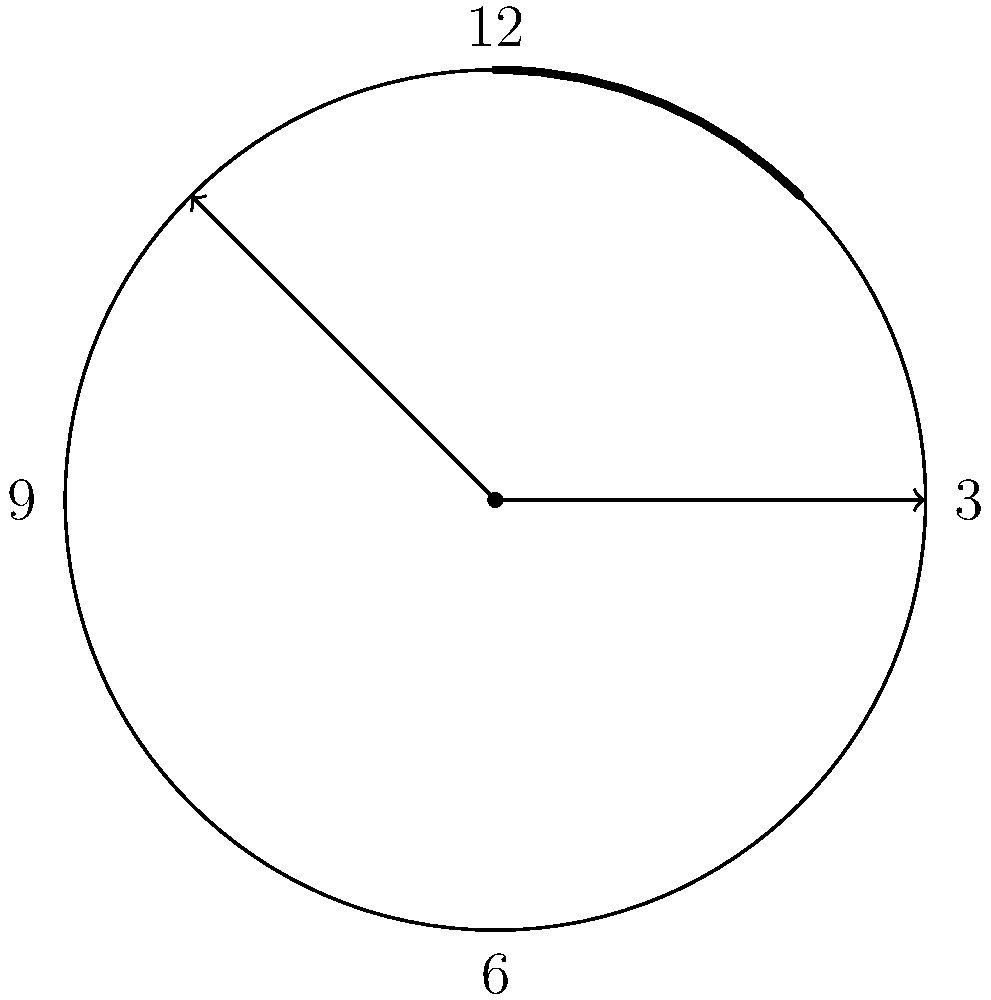As a busy working mother, you often find yourself glancing at the clock to manage your time efficiently. One day, while waiting for your nanny to arrive, you notice the clock hands forming a unique pattern. The hour hand is pointing exactly at 3, and the minute hand is precisely halfway between 12 and 1. If the clock face has a radius of 10 inches, what is the area of the sector formed by the two clock hands? Let's approach this step-by-step:

1) First, we need to determine the angle between the clock hands:
   - The hour hand points at 3, which is at 90°
   - The minute hand is halfway between 12 and 1, which is at 15° (360° ÷ 12 × 0.5)
   - The angle between them is 90° - 15° = 75°

2) The formula for the area of a sector is:
   $A = \frac{1}{2} r^2 \theta$
   Where $r$ is the radius and $\theta$ is the angle in radians

3) We need to convert 75° to radians:
   $75° \times \frac{\pi}{180°} = \frac{5\pi}{12}$ radians

4) Now we can plug in our values:
   $A = \frac{1}{2} \times 10^2 \times \frac{5\pi}{12}$

5) Simplify:
   $A = \frac{500\pi}{24} = \frac{125\pi}{6}$ square inches

Therefore, the area of the sector formed by the clock hands is $\frac{125\pi}{6}$ square inches.
Answer: $\frac{125\pi}{6}$ square inches 